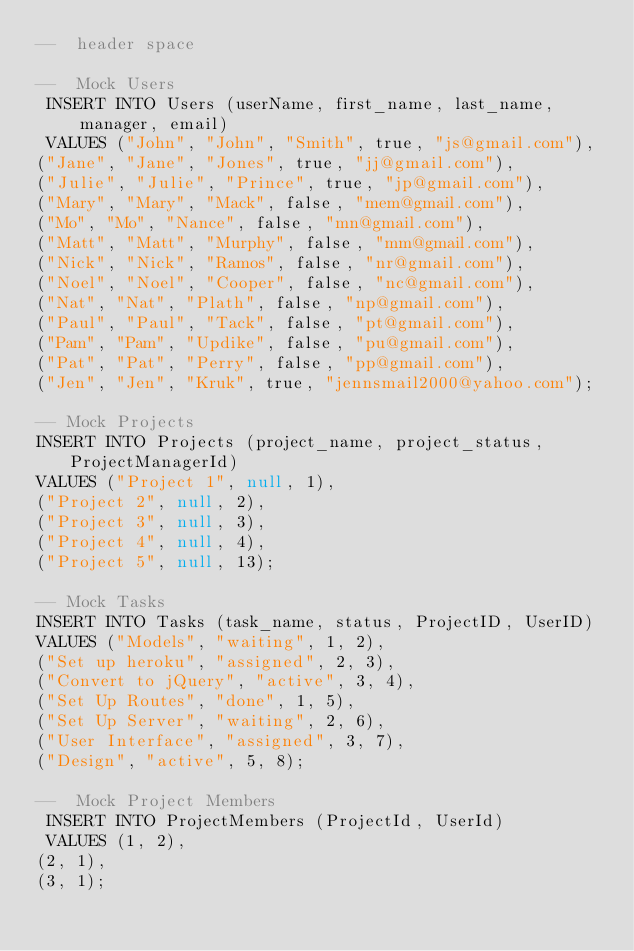<code> <loc_0><loc_0><loc_500><loc_500><_SQL_>--  header space 
 
--  Mock Users
 INSERT INTO Users (userName, first_name, last_name, manager, email)
 VALUES ("John", "John", "Smith", true, "js@gmail.com"),
("Jane", "Jane", "Jones", true, "jj@gmail.com"),
("Julie", "Julie", "Prince", true, "jp@gmail.com"),
("Mary", "Mary", "Mack", false, "mem@gmail.com"),
("Mo", "Mo", "Nance", false, "mn@gmail.com"),
("Matt", "Matt", "Murphy", false, "mm@gmail.com"),
("Nick", "Nick", "Ramos", false, "nr@gmail.com"),
("Noel", "Noel", "Cooper", false, "nc@gmail.com"),
("Nat", "Nat", "Plath", false, "np@gmail.com"),
("Paul", "Paul", "Tack", false, "pt@gmail.com"),
("Pam", "Pam", "Updike", false, "pu@gmail.com"),
("Pat", "Pat", "Perry", false, "pp@gmail.com"),
("Jen", "Jen", "Kruk", true, "jennsmail2000@yahoo.com");

-- Mock Projects 
INSERT INTO Projects (project_name, project_status, ProjectManagerId)
VALUES ("Project 1", null, 1),
("Project 2", null, 2),
("Project 3", null, 3),
("Project 4", null, 4),
("Project 5", null, 13);

-- Mock Tasks 
INSERT INTO Tasks (task_name, status, ProjectID, UserID)
VALUES ("Models", "waiting", 1, 2),
("Set up heroku", "assigned", 2, 3),
("Convert to jQuery", "active", 3, 4),
("Set Up Routes", "done", 1, 5),
("Set Up Server", "waiting", 2, 6),
("User Interface", "assigned", 3, 7),
("Design", "active", 5, 8);

--  Mock Project Members
 INSERT INTO ProjectMembers (ProjectId, UserId)
 VALUES (1, 2),
(2, 1),
(3, 1);</code> 